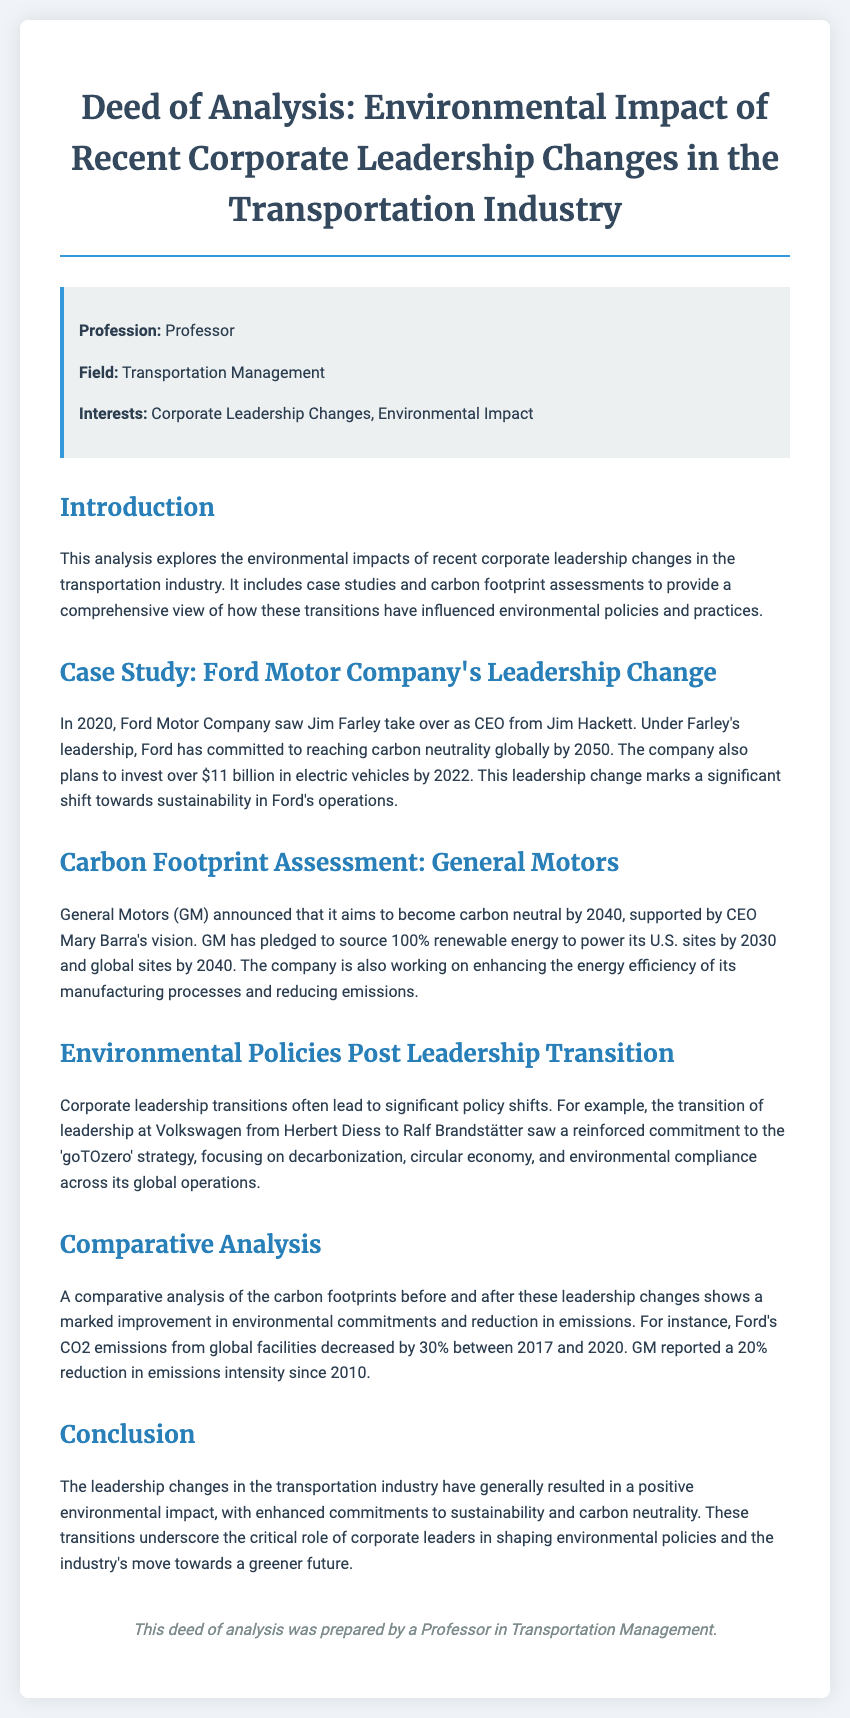What year did Jim Farley become CEO of Ford Motor Company? The document states that Jim Farley took over as CEO in 2020.
Answer: 2020 What is Ford Motor Company's carbon neutrality target year? According to the document, Ford aims to reach carbon neutrality globally by 2050.
Answer: 2050 How much does GM plan to invest in renewable energy for U.S. sites by 2030? The document mentions that GM pledged to source 100% renewable energy to power its U.S. sites by 2030.
Answer: 100% What strategy did Volkswagen reinforce after its leadership transition? The document highlights the 'goTOzero' strategy as the focus for Volkswagen's leadership transition.
Answer: goTOzero What percentage did Ford's CO2 emissions decrease between 2017 and 2020? The document states that Ford's CO2 emissions decreased by 30% during that period.
Answer: 30% What is Mary Barra's position at General Motors? The document identifies Mary Barra as the CEO of General Motors.
Answer: CEO What environmental commitment did GM announce for 2040? The document indicates that GM aims to become carbon neutral by 2040.
Answer: carbon neutral Which company adopted the 'goTOzero' strategy? Volkswagen is noted for adopting the 'goTOzero' strategy in the document.
Answer: Volkswagen What aspect do corporate leadership transitions influence according to the document? The document asserts these transitions influence environmental policies and practices.
Answer: environmental policies and practices 